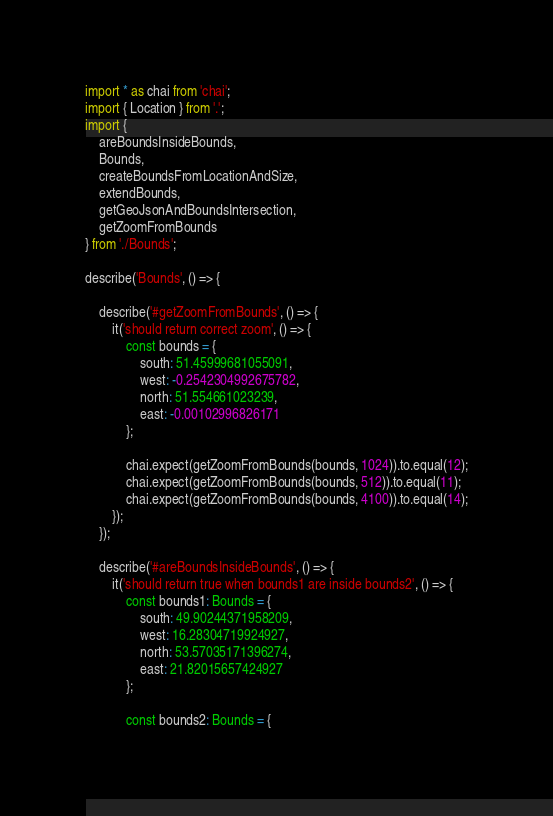<code> <loc_0><loc_0><loc_500><loc_500><_TypeScript_>import * as chai from 'chai';
import { Location } from '.';
import {
	areBoundsInsideBounds,
	Bounds,
	createBoundsFromLocationAndSize,
	extendBounds,
	getGeoJsonAndBoundsIntersection,
	getZoomFromBounds
} from './Bounds';

describe('Bounds', () => {

	describe('#getZoomFromBounds', () => {
		it('should return correct zoom', () => {
			const bounds = {
				south: 51.45999681055091,
				west: -0.2542304992675782,
				north: 51.554661023239,
				east: -0.00102996826171
			};

			chai.expect(getZoomFromBounds(bounds, 1024)).to.equal(12);
			chai.expect(getZoomFromBounds(bounds, 512)).to.equal(11);
			chai.expect(getZoomFromBounds(bounds, 4100)).to.equal(14);
		});
	});

	describe('#areBoundsInsideBounds', () => {
		it('should return true when bounds1 are inside bounds2', () => {
			const bounds1: Bounds = {
				south: 49.90244371958209,
				west: 16.28304719924927,
				north: 53.57035171396274,
				east: 21.82015657424927
			};

			const bounds2: Bounds = {</code> 